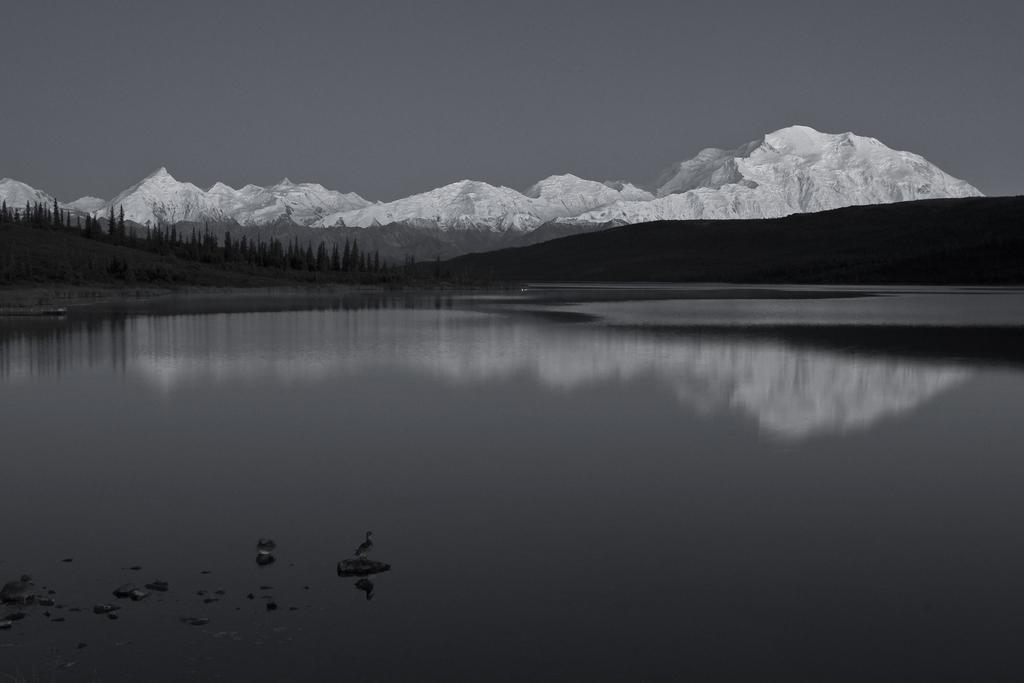What is the main element present in the image? There is water in the image. What type of natural vegetation can be seen in the image? There are trees in the image. What geographical features are visible in the image? There are hills in the image. What is visible at the top of the image? The sky is visible at the top of the image. What type of nerve can be seen in the image? There is no nerve present in the image; it features water, trees, hills, and the sky. 